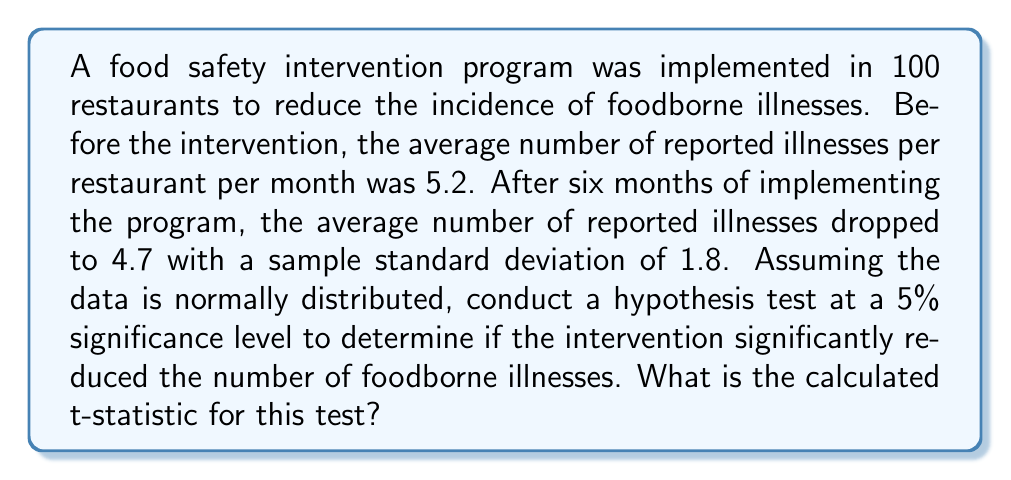Provide a solution to this math problem. To determine if the intervention significantly reduced the number of foodborne illnesses, we'll conduct a one-tailed t-test. Here's the step-by-step process:

1. Set up the hypotheses:
   $H_0: \mu = 5.2$ (null hypothesis: no change in mean illnesses)
   $H_a: \mu < 5.2$ (alternative hypothesis: mean illnesses decreased)

2. Choose the significance level: $\alpha = 0.05$ (given in the question)

3. Calculate the t-statistic using the formula:
   $$t = \frac{\bar{x} - \mu_0}{s / \sqrt{n}}$$
   
   Where:
   $\bar{x} = 4.7$ (sample mean after intervention)
   $\mu_0 = 5.2$ (hypothesized population mean, i.e., before intervention)
   $s = 1.8$ (sample standard deviation)
   $n = 100$ (sample size)

4. Plug in the values:
   $$t = \frac{4.7 - 5.2}{1.8 / \sqrt{100}}$$
   
5. Simplify:
   $$t = \frac{-0.5}{1.8 / 10} = \frac{-0.5}{0.18} = -2.778$$

The calculated t-statistic is -2.778. This value would be compared to the critical t-value or used to calculate the p-value to make a decision about the null hypothesis, but the question only asks for the t-statistic calculation.
Answer: -2.778 